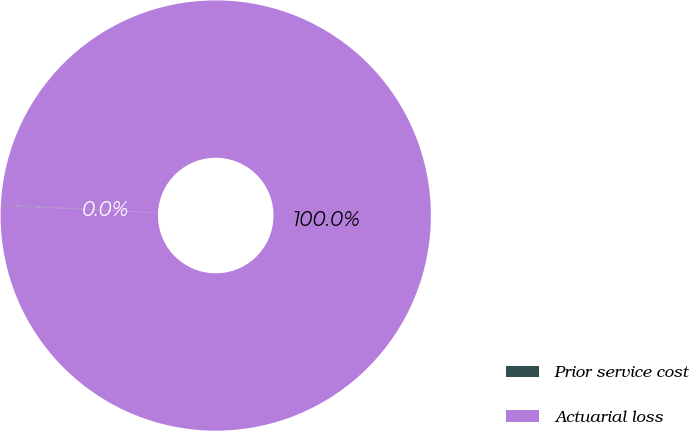<chart> <loc_0><loc_0><loc_500><loc_500><pie_chart><fcel>Prior service cost<fcel>Actuarial loss<nl><fcel>0.04%<fcel>99.96%<nl></chart> 